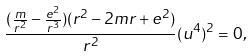<formula> <loc_0><loc_0><loc_500><loc_500>\frac { ( \frac { m } { r ^ { 2 } } - \frac { e ^ { 2 } } { r ^ { 3 } } ) ( r ^ { 2 } - 2 m r + e ^ { 2 } ) } { r ^ { 2 } } ( u ^ { 4 } ) ^ { 2 } = 0 ,</formula> 